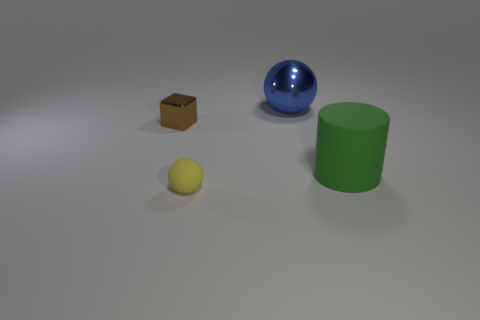Is there a cylinder that has the same color as the block?
Provide a short and direct response. No. There is a small object to the right of the metallic block; is its color the same as the big thing to the right of the large blue sphere?
Ensure brevity in your answer.  No. Are there any other small brown things that have the same material as the brown object?
Your response must be concise. No. What color is the tiny block?
Make the answer very short. Brown. What size is the sphere that is behind the matte object left of the large thing that is left of the green cylinder?
Ensure brevity in your answer.  Large. What number of other objects are the same shape as the big green object?
Your answer should be compact. 0. What is the color of the thing that is in front of the big ball and behind the green cylinder?
Ensure brevity in your answer.  Brown. There is a rubber object that is in front of the green thing; is it the same color as the metallic sphere?
Your answer should be compact. No. How many spheres are blue metal things or big green objects?
Provide a short and direct response. 1. There is a large object to the right of the big metal ball; what shape is it?
Ensure brevity in your answer.  Cylinder. 